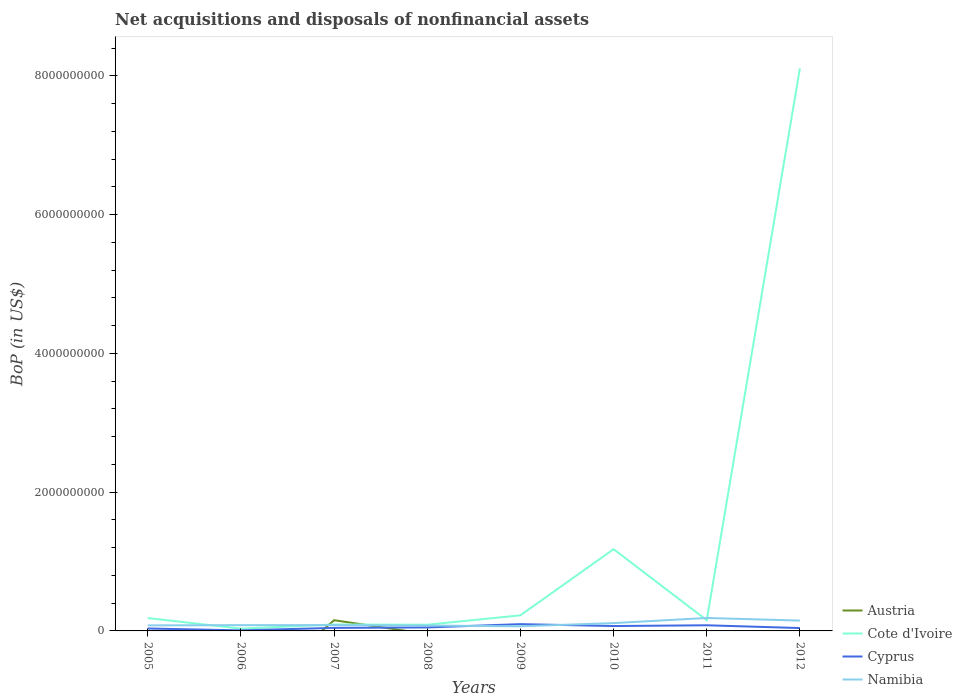How many different coloured lines are there?
Provide a succinct answer. 4. Is the number of lines equal to the number of legend labels?
Your answer should be very brief. No. What is the total Balance of Payments in Cyprus in the graph?
Your answer should be very brief. -3.55e+07. What is the difference between the highest and the second highest Balance of Payments in Namibia?
Give a very brief answer. 1.20e+08. How many lines are there?
Ensure brevity in your answer.  4. How many years are there in the graph?
Offer a very short reply. 8. Are the values on the major ticks of Y-axis written in scientific E-notation?
Offer a very short reply. No. Does the graph contain grids?
Your response must be concise. No. How many legend labels are there?
Provide a succinct answer. 4. How are the legend labels stacked?
Your answer should be compact. Vertical. What is the title of the graph?
Keep it short and to the point. Net acquisitions and disposals of nonfinancial assets. Does "Andorra" appear as one of the legend labels in the graph?
Make the answer very short. No. What is the label or title of the X-axis?
Provide a short and direct response. Years. What is the label or title of the Y-axis?
Provide a short and direct response. BoP (in US$). What is the BoP (in US$) of Cote d'Ivoire in 2005?
Provide a short and direct response. 1.85e+08. What is the BoP (in US$) in Cyprus in 2005?
Provide a short and direct response. 3.49e+07. What is the BoP (in US$) of Namibia in 2005?
Offer a terse response. 7.97e+07. What is the BoP (in US$) of Cote d'Ivoire in 2006?
Your response must be concise. 3.30e+07. What is the BoP (in US$) in Cyprus in 2006?
Give a very brief answer. 7.90e+06. What is the BoP (in US$) of Namibia in 2006?
Offer a terse response. 8.34e+07. What is the BoP (in US$) of Austria in 2007?
Give a very brief answer. 1.54e+08. What is the BoP (in US$) of Cote d'Ivoire in 2007?
Ensure brevity in your answer.  9.29e+07. What is the BoP (in US$) in Cyprus in 2007?
Your answer should be very brief. 4.38e+07. What is the BoP (in US$) in Namibia in 2007?
Your answer should be compact. 8.34e+07. What is the BoP (in US$) in Austria in 2008?
Offer a very short reply. 0. What is the BoP (in US$) in Cote d'Ivoire in 2008?
Offer a very short reply. 8.93e+07. What is the BoP (in US$) in Cyprus in 2008?
Give a very brief answer. 5.03e+07. What is the BoP (in US$) of Namibia in 2008?
Offer a very short reply. 7.72e+07. What is the BoP (in US$) in Cote d'Ivoire in 2009?
Your response must be concise. 2.25e+08. What is the BoP (in US$) of Cyprus in 2009?
Your response must be concise. 9.77e+07. What is the BoP (in US$) in Namibia in 2009?
Your answer should be very brief. 6.68e+07. What is the BoP (in US$) of Austria in 2010?
Keep it short and to the point. 0. What is the BoP (in US$) of Cote d'Ivoire in 2010?
Provide a succinct answer. 1.18e+09. What is the BoP (in US$) of Cyprus in 2010?
Your answer should be very brief. 7.04e+07. What is the BoP (in US$) of Namibia in 2010?
Your response must be concise. 1.13e+08. What is the BoP (in US$) in Cote d'Ivoire in 2011?
Keep it short and to the point. 1.55e+08. What is the BoP (in US$) of Cyprus in 2011?
Offer a terse response. 8.13e+07. What is the BoP (in US$) of Namibia in 2011?
Your response must be concise. 1.87e+08. What is the BoP (in US$) of Cote d'Ivoire in 2012?
Provide a succinct answer. 8.11e+09. What is the BoP (in US$) in Cyprus in 2012?
Give a very brief answer. 4.13e+07. What is the BoP (in US$) of Namibia in 2012?
Make the answer very short. 1.49e+08. Across all years, what is the maximum BoP (in US$) in Austria?
Give a very brief answer. 1.54e+08. Across all years, what is the maximum BoP (in US$) in Cote d'Ivoire?
Your answer should be compact. 8.11e+09. Across all years, what is the maximum BoP (in US$) in Cyprus?
Your answer should be very brief. 9.77e+07. Across all years, what is the maximum BoP (in US$) of Namibia?
Provide a short and direct response. 1.87e+08. Across all years, what is the minimum BoP (in US$) of Austria?
Your answer should be compact. 0. Across all years, what is the minimum BoP (in US$) in Cote d'Ivoire?
Give a very brief answer. 3.30e+07. Across all years, what is the minimum BoP (in US$) of Cyprus?
Your answer should be compact. 7.90e+06. Across all years, what is the minimum BoP (in US$) in Namibia?
Provide a succinct answer. 6.68e+07. What is the total BoP (in US$) of Austria in the graph?
Provide a succinct answer. 1.54e+08. What is the total BoP (in US$) of Cote d'Ivoire in the graph?
Make the answer very short. 1.01e+1. What is the total BoP (in US$) in Cyprus in the graph?
Your answer should be very brief. 4.28e+08. What is the total BoP (in US$) of Namibia in the graph?
Provide a short and direct response. 8.39e+08. What is the difference between the BoP (in US$) in Cote d'Ivoire in 2005 and that in 2006?
Offer a very short reply. 1.52e+08. What is the difference between the BoP (in US$) of Cyprus in 2005 and that in 2006?
Offer a very short reply. 2.70e+07. What is the difference between the BoP (in US$) in Namibia in 2005 and that in 2006?
Provide a short and direct response. -3.73e+06. What is the difference between the BoP (in US$) in Cote d'Ivoire in 2005 and that in 2007?
Your answer should be very brief. 9.24e+07. What is the difference between the BoP (in US$) in Cyprus in 2005 and that in 2007?
Ensure brevity in your answer.  -8.91e+06. What is the difference between the BoP (in US$) of Namibia in 2005 and that in 2007?
Offer a terse response. -3.75e+06. What is the difference between the BoP (in US$) of Cote d'Ivoire in 2005 and that in 2008?
Offer a terse response. 9.59e+07. What is the difference between the BoP (in US$) in Cyprus in 2005 and that in 2008?
Offer a terse response. -1.54e+07. What is the difference between the BoP (in US$) in Namibia in 2005 and that in 2008?
Provide a succinct answer. 2.45e+06. What is the difference between the BoP (in US$) in Cote d'Ivoire in 2005 and that in 2009?
Give a very brief answer. -3.97e+07. What is the difference between the BoP (in US$) in Cyprus in 2005 and that in 2009?
Provide a short and direct response. -6.28e+07. What is the difference between the BoP (in US$) in Namibia in 2005 and that in 2009?
Make the answer very short. 1.29e+07. What is the difference between the BoP (in US$) of Cote d'Ivoire in 2005 and that in 2010?
Ensure brevity in your answer.  -9.93e+08. What is the difference between the BoP (in US$) of Cyprus in 2005 and that in 2010?
Your answer should be compact. -3.55e+07. What is the difference between the BoP (in US$) in Namibia in 2005 and that in 2010?
Your answer should be compact. -3.29e+07. What is the difference between the BoP (in US$) of Cote d'Ivoire in 2005 and that in 2011?
Your response must be concise. 3.06e+07. What is the difference between the BoP (in US$) of Cyprus in 2005 and that in 2011?
Your response must be concise. -4.64e+07. What is the difference between the BoP (in US$) of Namibia in 2005 and that in 2011?
Your answer should be very brief. -1.07e+08. What is the difference between the BoP (in US$) in Cote d'Ivoire in 2005 and that in 2012?
Provide a succinct answer. -7.93e+09. What is the difference between the BoP (in US$) of Cyprus in 2005 and that in 2012?
Your answer should be very brief. -6.39e+06. What is the difference between the BoP (in US$) of Namibia in 2005 and that in 2012?
Your response must be concise. -6.92e+07. What is the difference between the BoP (in US$) of Cote d'Ivoire in 2006 and that in 2007?
Provide a short and direct response. -5.99e+07. What is the difference between the BoP (in US$) in Cyprus in 2006 and that in 2007?
Give a very brief answer. -3.59e+07. What is the difference between the BoP (in US$) in Namibia in 2006 and that in 2007?
Your answer should be compact. -2.69e+04. What is the difference between the BoP (in US$) in Cote d'Ivoire in 2006 and that in 2008?
Offer a very short reply. -5.63e+07. What is the difference between the BoP (in US$) in Cyprus in 2006 and that in 2008?
Provide a succinct answer. -4.24e+07. What is the difference between the BoP (in US$) in Namibia in 2006 and that in 2008?
Offer a terse response. 6.18e+06. What is the difference between the BoP (in US$) of Cote d'Ivoire in 2006 and that in 2009?
Ensure brevity in your answer.  -1.92e+08. What is the difference between the BoP (in US$) in Cyprus in 2006 and that in 2009?
Provide a short and direct response. -8.98e+07. What is the difference between the BoP (in US$) in Namibia in 2006 and that in 2009?
Provide a short and direct response. 1.66e+07. What is the difference between the BoP (in US$) of Cote d'Ivoire in 2006 and that in 2010?
Make the answer very short. -1.15e+09. What is the difference between the BoP (in US$) of Cyprus in 2006 and that in 2010?
Offer a very short reply. -6.25e+07. What is the difference between the BoP (in US$) in Namibia in 2006 and that in 2010?
Make the answer very short. -2.92e+07. What is the difference between the BoP (in US$) of Cote d'Ivoire in 2006 and that in 2011?
Your answer should be very brief. -1.22e+08. What is the difference between the BoP (in US$) of Cyprus in 2006 and that in 2011?
Your response must be concise. -7.34e+07. What is the difference between the BoP (in US$) of Namibia in 2006 and that in 2011?
Provide a succinct answer. -1.03e+08. What is the difference between the BoP (in US$) of Cote d'Ivoire in 2006 and that in 2012?
Make the answer very short. -8.08e+09. What is the difference between the BoP (in US$) in Cyprus in 2006 and that in 2012?
Provide a short and direct response. -3.34e+07. What is the difference between the BoP (in US$) of Namibia in 2006 and that in 2012?
Provide a short and direct response. -6.54e+07. What is the difference between the BoP (in US$) in Cote d'Ivoire in 2007 and that in 2008?
Provide a short and direct response. 3.56e+06. What is the difference between the BoP (in US$) in Cyprus in 2007 and that in 2008?
Your answer should be compact. -6.48e+06. What is the difference between the BoP (in US$) of Namibia in 2007 and that in 2008?
Your response must be concise. 6.20e+06. What is the difference between the BoP (in US$) of Cote d'Ivoire in 2007 and that in 2009?
Provide a short and direct response. -1.32e+08. What is the difference between the BoP (in US$) of Cyprus in 2007 and that in 2009?
Ensure brevity in your answer.  -5.39e+07. What is the difference between the BoP (in US$) of Namibia in 2007 and that in 2009?
Give a very brief answer. 1.66e+07. What is the difference between the BoP (in US$) of Cote d'Ivoire in 2007 and that in 2010?
Provide a short and direct response. -1.09e+09. What is the difference between the BoP (in US$) in Cyprus in 2007 and that in 2010?
Your response must be concise. -2.66e+07. What is the difference between the BoP (in US$) in Namibia in 2007 and that in 2010?
Your answer should be very brief. -2.92e+07. What is the difference between the BoP (in US$) in Cote d'Ivoire in 2007 and that in 2011?
Your response must be concise. -6.18e+07. What is the difference between the BoP (in US$) in Cyprus in 2007 and that in 2011?
Provide a short and direct response. -3.75e+07. What is the difference between the BoP (in US$) in Namibia in 2007 and that in 2011?
Your answer should be very brief. -1.03e+08. What is the difference between the BoP (in US$) in Cote d'Ivoire in 2007 and that in 2012?
Ensure brevity in your answer.  -8.02e+09. What is the difference between the BoP (in US$) of Cyprus in 2007 and that in 2012?
Provide a short and direct response. 2.52e+06. What is the difference between the BoP (in US$) in Namibia in 2007 and that in 2012?
Give a very brief answer. -6.54e+07. What is the difference between the BoP (in US$) in Cote d'Ivoire in 2008 and that in 2009?
Offer a terse response. -1.36e+08. What is the difference between the BoP (in US$) in Cyprus in 2008 and that in 2009?
Keep it short and to the point. -4.74e+07. What is the difference between the BoP (in US$) in Namibia in 2008 and that in 2009?
Your answer should be compact. 1.04e+07. What is the difference between the BoP (in US$) in Cote d'Ivoire in 2008 and that in 2010?
Your answer should be compact. -1.09e+09. What is the difference between the BoP (in US$) of Cyprus in 2008 and that in 2010?
Give a very brief answer. -2.01e+07. What is the difference between the BoP (in US$) of Namibia in 2008 and that in 2010?
Provide a succinct answer. -3.54e+07. What is the difference between the BoP (in US$) of Cote d'Ivoire in 2008 and that in 2011?
Keep it short and to the point. -6.53e+07. What is the difference between the BoP (in US$) of Cyprus in 2008 and that in 2011?
Your response must be concise. -3.10e+07. What is the difference between the BoP (in US$) in Namibia in 2008 and that in 2011?
Ensure brevity in your answer.  -1.10e+08. What is the difference between the BoP (in US$) in Cote d'Ivoire in 2008 and that in 2012?
Your answer should be compact. -8.02e+09. What is the difference between the BoP (in US$) in Cyprus in 2008 and that in 2012?
Keep it short and to the point. 9.00e+06. What is the difference between the BoP (in US$) in Namibia in 2008 and that in 2012?
Your response must be concise. -7.16e+07. What is the difference between the BoP (in US$) of Cote d'Ivoire in 2009 and that in 2010?
Offer a terse response. -9.53e+08. What is the difference between the BoP (in US$) in Cyprus in 2009 and that in 2010?
Give a very brief answer. 2.73e+07. What is the difference between the BoP (in US$) in Namibia in 2009 and that in 2010?
Provide a succinct answer. -4.58e+07. What is the difference between the BoP (in US$) of Cote d'Ivoire in 2009 and that in 2011?
Your response must be concise. 7.03e+07. What is the difference between the BoP (in US$) of Cyprus in 2009 and that in 2011?
Your answer should be compact. 1.64e+07. What is the difference between the BoP (in US$) in Namibia in 2009 and that in 2011?
Your response must be concise. -1.20e+08. What is the difference between the BoP (in US$) of Cote d'Ivoire in 2009 and that in 2012?
Offer a terse response. -7.89e+09. What is the difference between the BoP (in US$) in Cyprus in 2009 and that in 2012?
Your answer should be very brief. 5.64e+07. What is the difference between the BoP (in US$) in Namibia in 2009 and that in 2012?
Provide a succinct answer. -8.21e+07. What is the difference between the BoP (in US$) of Cote d'Ivoire in 2010 and that in 2011?
Provide a succinct answer. 1.02e+09. What is the difference between the BoP (in US$) of Cyprus in 2010 and that in 2011?
Make the answer very short. -1.09e+07. What is the difference between the BoP (in US$) in Namibia in 2010 and that in 2011?
Make the answer very short. -7.42e+07. What is the difference between the BoP (in US$) of Cote d'Ivoire in 2010 and that in 2012?
Your answer should be compact. -6.93e+09. What is the difference between the BoP (in US$) of Cyprus in 2010 and that in 2012?
Keep it short and to the point. 2.91e+07. What is the difference between the BoP (in US$) in Namibia in 2010 and that in 2012?
Keep it short and to the point. -3.63e+07. What is the difference between the BoP (in US$) of Cote d'Ivoire in 2011 and that in 2012?
Your answer should be compact. -7.96e+09. What is the difference between the BoP (in US$) in Cyprus in 2011 and that in 2012?
Offer a very short reply. 4.01e+07. What is the difference between the BoP (in US$) of Namibia in 2011 and that in 2012?
Provide a succinct answer. 3.79e+07. What is the difference between the BoP (in US$) in Cote d'Ivoire in 2005 and the BoP (in US$) in Cyprus in 2006?
Ensure brevity in your answer.  1.77e+08. What is the difference between the BoP (in US$) of Cote d'Ivoire in 2005 and the BoP (in US$) of Namibia in 2006?
Make the answer very short. 1.02e+08. What is the difference between the BoP (in US$) of Cyprus in 2005 and the BoP (in US$) of Namibia in 2006?
Offer a terse response. -4.85e+07. What is the difference between the BoP (in US$) in Cote d'Ivoire in 2005 and the BoP (in US$) in Cyprus in 2007?
Give a very brief answer. 1.41e+08. What is the difference between the BoP (in US$) in Cote d'Ivoire in 2005 and the BoP (in US$) in Namibia in 2007?
Make the answer very short. 1.02e+08. What is the difference between the BoP (in US$) of Cyprus in 2005 and the BoP (in US$) of Namibia in 2007?
Offer a terse response. -4.85e+07. What is the difference between the BoP (in US$) of Cote d'Ivoire in 2005 and the BoP (in US$) of Cyprus in 2008?
Keep it short and to the point. 1.35e+08. What is the difference between the BoP (in US$) in Cote d'Ivoire in 2005 and the BoP (in US$) in Namibia in 2008?
Offer a very short reply. 1.08e+08. What is the difference between the BoP (in US$) of Cyprus in 2005 and the BoP (in US$) of Namibia in 2008?
Offer a very short reply. -4.23e+07. What is the difference between the BoP (in US$) of Cote d'Ivoire in 2005 and the BoP (in US$) of Cyprus in 2009?
Offer a terse response. 8.75e+07. What is the difference between the BoP (in US$) in Cote d'Ivoire in 2005 and the BoP (in US$) in Namibia in 2009?
Give a very brief answer. 1.18e+08. What is the difference between the BoP (in US$) of Cyprus in 2005 and the BoP (in US$) of Namibia in 2009?
Provide a succinct answer. -3.19e+07. What is the difference between the BoP (in US$) of Cote d'Ivoire in 2005 and the BoP (in US$) of Cyprus in 2010?
Keep it short and to the point. 1.15e+08. What is the difference between the BoP (in US$) in Cote d'Ivoire in 2005 and the BoP (in US$) in Namibia in 2010?
Make the answer very short. 7.27e+07. What is the difference between the BoP (in US$) in Cyprus in 2005 and the BoP (in US$) in Namibia in 2010?
Keep it short and to the point. -7.77e+07. What is the difference between the BoP (in US$) of Cote d'Ivoire in 2005 and the BoP (in US$) of Cyprus in 2011?
Make the answer very short. 1.04e+08. What is the difference between the BoP (in US$) in Cote d'Ivoire in 2005 and the BoP (in US$) in Namibia in 2011?
Your response must be concise. -1.54e+06. What is the difference between the BoP (in US$) in Cyprus in 2005 and the BoP (in US$) in Namibia in 2011?
Your answer should be very brief. -1.52e+08. What is the difference between the BoP (in US$) of Cote d'Ivoire in 2005 and the BoP (in US$) of Cyprus in 2012?
Provide a succinct answer. 1.44e+08. What is the difference between the BoP (in US$) in Cote d'Ivoire in 2005 and the BoP (in US$) in Namibia in 2012?
Your response must be concise. 3.64e+07. What is the difference between the BoP (in US$) in Cyprus in 2005 and the BoP (in US$) in Namibia in 2012?
Provide a short and direct response. -1.14e+08. What is the difference between the BoP (in US$) of Cote d'Ivoire in 2006 and the BoP (in US$) of Cyprus in 2007?
Provide a succinct answer. -1.08e+07. What is the difference between the BoP (in US$) of Cote d'Ivoire in 2006 and the BoP (in US$) of Namibia in 2007?
Provide a succinct answer. -5.04e+07. What is the difference between the BoP (in US$) in Cyprus in 2006 and the BoP (in US$) in Namibia in 2007?
Your answer should be compact. -7.55e+07. What is the difference between the BoP (in US$) in Cote d'Ivoire in 2006 and the BoP (in US$) in Cyprus in 2008?
Your response must be concise. -1.73e+07. What is the difference between the BoP (in US$) of Cote d'Ivoire in 2006 and the BoP (in US$) of Namibia in 2008?
Your answer should be compact. -4.42e+07. What is the difference between the BoP (in US$) of Cyprus in 2006 and the BoP (in US$) of Namibia in 2008?
Make the answer very short. -6.93e+07. What is the difference between the BoP (in US$) in Cote d'Ivoire in 2006 and the BoP (in US$) in Cyprus in 2009?
Your response must be concise. -6.47e+07. What is the difference between the BoP (in US$) of Cote d'Ivoire in 2006 and the BoP (in US$) of Namibia in 2009?
Provide a short and direct response. -3.38e+07. What is the difference between the BoP (in US$) of Cyprus in 2006 and the BoP (in US$) of Namibia in 2009?
Give a very brief answer. -5.89e+07. What is the difference between the BoP (in US$) of Cote d'Ivoire in 2006 and the BoP (in US$) of Cyprus in 2010?
Provide a succinct answer. -3.74e+07. What is the difference between the BoP (in US$) in Cote d'Ivoire in 2006 and the BoP (in US$) in Namibia in 2010?
Ensure brevity in your answer.  -7.96e+07. What is the difference between the BoP (in US$) in Cyprus in 2006 and the BoP (in US$) in Namibia in 2010?
Offer a very short reply. -1.05e+08. What is the difference between the BoP (in US$) in Cote d'Ivoire in 2006 and the BoP (in US$) in Cyprus in 2011?
Keep it short and to the point. -4.83e+07. What is the difference between the BoP (in US$) in Cote d'Ivoire in 2006 and the BoP (in US$) in Namibia in 2011?
Provide a succinct answer. -1.54e+08. What is the difference between the BoP (in US$) in Cyprus in 2006 and the BoP (in US$) in Namibia in 2011?
Give a very brief answer. -1.79e+08. What is the difference between the BoP (in US$) of Cote d'Ivoire in 2006 and the BoP (in US$) of Cyprus in 2012?
Your response must be concise. -8.29e+06. What is the difference between the BoP (in US$) of Cote d'Ivoire in 2006 and the BoP (in US$) of Namibia in 2012?
Offer a terse response. -1.16e+08. What is the difference between the BoP (in US$) of Cyprus in 2006 and the BoP (in US$) of Namibia in 2012?
Offer a very short reply. -1.41e+08. What is the difference between the BoP (in US$) of Austria in 2007 and the BoP (in US$) of Cote d'Ivoire in 2008?
Your response must be concise. 6.51e+07. What is the difference between the BoP (in US$) of Austria in 2007 and the BoP (in US$) of Cyprus in 2008?
Offer a terse response. 1.04e+08. What is the difference between the BoP (in US$) in Austria in 2007 and the BoP (in US$) in Namibia in 2008?
Provide a succinct answer. 7.72e+07. What is the difference between the BoP (in US$) in Cote d'Ivoire in 2007 and the BoP (in US$) in Cyprus in 2008?
Provide a succinct answer. 4.26e+07. What is the difference between the BoP (in US$) in Cote d'Ivoire in 2007 and the BoP (in US$) in Namibia in 2008?
Provide a succinct answer. 1.57e+07. What is the difference between the BoP (in US$) of Cyprus in 2007 and the BoP (in US$) of Namibia in 2008?
Offer a very short reply. -3.34e+07. What is the difference between the BoP (in US$) of Austria in 2007 and the BoP (in US$) of Cote d'Ivoire in 2009?
Your answer should be compact. -7.05e+07. What is the difference between the BoP (in US$) in Austria in 2007 and the BoP (in US$) in Cyprus in 2009?
Make the answer very short. 5.67e+07. What is the difference between the BoP (in US$) of Austria in 2007 and the BoP (in US$) of Namibia in 2009?
Ensure brevity in your answer.  8.76e+07. What is the difference between the BoP (in US$) in Cote d'Ivoire in 2007 and the BoP (in US$) in Cyprus in 2009?
Give a very brief answer. -4.82e+06. What is the difference between the BoP (in US$) of Cote d'Ivoire in 2007 and the BoP (in US$) of Namibia in 2009?
Give a very brief answer. 2.61e+07. What is the difference between the BoP (in US$) of Cyprus in 2007 and the BoP (in US$) of Namibia in 2009?
Keep it short and to the point. -2.30e+07. What is the difference between the BoP (in US$) of Austria in 2007 and the BoP (in US$) of Cote d'Ivoire in 2010?
Give a very brief answer. -1.02e+09. What is the difference between the BoP (in US$) in Austria in 2007 and the BoP (in US$) in Cyprus in 2010?
Keep it short and to the point. 8.40e+07. What is the difference between the BoP (in US$) of Austria in 2007 and the BoP (in US$) of Namibia in 2010?
Ensure brevity in your answer.  4.18e+07. What is the difference between the BoP (in US$) in Cote d'Ivoire in 2007 and the BoP (in US$) in Cyprus in 2010?
Make the answer very short. 2.25e+07. What is the difference between the BoP (in US$) in Cote d'Ivoire in 2007 and the BoP (in US$) in Namibia in 2010?
Offer a terse response. -1.97e+07. What is the difference between the BoP (in US$) of Cyprus in 2007 and the BoP (in US$) of Namibia in 2010?
Provide a short and direct response. -6.88e+07. What is the difference between the BoP (in US$) of Austria in 2007 and the BoP (in US$) of Cote d'Ivoire in 2011?
Provide a succinct answer. -2.55e+05. What is the difference between the BoP (in US$) of Austria in 2007 and the BoP (in US$) of Cyprus in 2011?
Offer a terse response. 7.31e+07. What is the difference between the BoP (in US$) in Austria in 2007 and the BoP (in US$) in Namibia in 2011?
Your response must be concise. -3.24e+07. What is the difference between the BoP (in US$) in Cote d'Ivoire in 2007 and the BoP (in US$) in Cyprus in 2011?
Your answer should be very brief. 1.16e+07. What is the difference between the BoP (in US$) in Cote d'Ivoire in 2007 and the BoP (in US$) in Namibia in 2011?
Provide a succinct answer. -9.39e+07. What is the difference between the BoP (in US$) of Cyprus in 2007 and the BoP (in US$) of Namibia in 2011?
Your answer should be very brief. -1.43e+08. What is the difference between the BoP (in US$) of Austria in 2007 and the BoP (in US$) of Cote d'Ivoire in 2012?
Give a very brief answer. -7.96e+09. What is the difference between the BoP (in US$) in Austria in 2007 and the BoP (in US$) in Cyprus in 2012?
Offer a terse response. 1.13e+08. What is the difference between the BoP (in US$) in Austria in 2007 and the BoP (in US$) in Namibia in 2012?
Offer a terse response. 5.57e+06. What is the difference between the BoP (in US$) in Cote d'Ivoire in 2007 and the BoP (in US$) in Cyprus in 2012?
Give a very brief answer. 5.16e+07. What is the difference between the BoP (in US$) of Cote d'Ivoire in 2007 and the BoP (in US$) of Namibia in 2012?
Your answer should be very brief. -5.59e+07. What is the difference between the BoP (in US$) of Cyprus in 2007 and the BoP (in US$) of Namibia in 2012?
Ensure brevity in your answer.  -1.05e+08. What is the difference between the BoP (in US$) in Cote d'Ivoire in 2008 and the BoP (in US$) in Cyprus in 2009?
Keep it short and to the point. -8.38e+06. What is the difference between the BoP (in US$) of Cote d'Ivoire in 2008 and the BoP (in US$) of Namibia in 2009?
Offer a terse response. 2.25e+07. What is the difference between the BoP (in US$) in Cyprus in 2008 and the BoP (in US$) in Namibia in 2009?
Provide a short and direct response. -1.65e+07. What is the difference between the BoP (in US$) in Cote d'Ivoire in 2008 and the BoP (in US$) in Cyprus in 2010?
Make the answer very short. 1.89e+07. What is the difference between the BoP (in US$) in Cote d'Ivoire in 2008 and the BoP (in US$) in Namibia in 2010?
Keep it short and to the point. -2.32e+07. What is the difference between the BoP (in US$) of Cyprus in 2008 and the BoP (in US$) of Namibia in 2010?
Provide a short and direct response. -6.23e+07. What is the difference between the BoP (in US$) of Cote d'Ivoire in 2008 and the BoP (in US$) of Cyprus in 2011?
Your response must be concise. 7.99e+06. What is the difference between the BoP (in US$) in Cote d'Ivoire in 2008 and the BoP (in US$) in Namibia in 2011?
Keep it short and to the point. -9.75e+07. What is the difference between the BoP (in US$) of Cyprus in 2008 and the BoP (in US$) of Namibia in 2011?
Provide a succinct answer. -1.36e+08. What is the difference between the BoP (in US$) in Cote d'Ivoire in 2008 and the BoP (in US$) in Cyprus in 2012?
Provide a short and direct response. 4.80e+07. What is the difference between the BoP (in US$) of Cote d'Ivoire in 2008 and the BoP (in US$) of Namibia in 2012?
Give a very brief answer. -5.95e+07. What is the difference between the BoP (in US$) in Cyprus in 2008 and the BoP (in US$) in Namibia in 2012?
Ensure brevity in your answer.  -9.86e+07. What is the difference between the BoP (in US$) of Cote d'Ivoire in 2009 and the BoP (in US$) of Cyprus in 2010?
Offer a terse response. 1.55e+08. What is the difference between the BoP (in US$) of Cote d'Ivoire in 2009 and the BoP (in US$) of Namibia in 2010?
Keep it short and to the point. 1.12e+08. What is the difference between the BoP (in US$) in Cyprus in 2009 and the BoP (in US$) in Namibia in 2010?
Provide a succinct answer. -1.49e+07. What is the difference between the BoP (in US$) in Cote d'Ivoire in 2009 and the BoP (in US$) in Cyprus in 2011?
Ensure brevity in your answer.  1.44e+08. What is the difference between the BoP (in US$) in Cote d'Ivoire in 2009 and the BoP (in US$) in Namibia in 2011?
Provide a short and direct response. 3.82e+07. What is the difference between the BoP (in US$) of Cyprus in 2009 and the BoP (in US$) of Namibia in 2011?
Offer a terse response. -8.91e+07. What is the difference between the BoP (in US$) in Cote d'Ivoire in 2009 and the BoP (in US$) in Cyprus in 2012?
Ensure brevity in your answer.  1.84e+08. What is the difference between the BoP (in US$) of Cote d'Ivoire in 2009 and the BoP (in US$) of Namibia in 2012?
Make the answer very short. 7.61e+07. What is the difference between the BoP (in US$) of Cyprus in 2009 and the BoP (in US$) of Namibia in 2012?
Your response must be concise. -5.11e+07. What is the difference between the BoP (in US$) of Cote d'Ivoire in 2010 and the BoP (in US$) of Cyprus in 2011?
Provide a short and direct response. 1.10e+09. What is the difference between the BoP (in US$) in Cote d'Ivoire in 2010 and the BoP (in US$) in Namibia in 2011?
Provide a succinct answer. 9.92e+08. What is the difference between the BoP (in US$) in Cyprus in 2010 and the BoP (in US$) in Namibia in 2011?
Offer a very short reply. -1.16e+08. What is the difference between the BoP (in US$) of Cote d'Ivoire in 2010 and the BoP (in US$) of Cyprus in 2012?
Keep it short and to the point. 1.14e+09. What is the difference between the BoP (in US$) of Cote d'Ivoire in 2010 and the BoP (in US$) of Namibia in 2012?
Offer a very short reply. 1.03e+09. What is the difference between the BoP (in US$) of Cyprus in 2010 and the BoP (in US$) of Namibia in 2012?
Make the answer very short. -7.84e+07. What is the difference between the BoP (in US$) of Cote d'Ivoire in 2011 and the BoP (in US$) of Cyprus in 2012?
Your answer should be compact. 1.13e+08. What is the difference between the BoP (in US$) in Cote d'Ivoire in 2011 and the BoP (in US$) in Namibia in 2012?
Your answer should be compact. 5.82e+06. What is the difference between the BoP (in US$) in Cyprus in 2011 and the BoP (in US$) in Namibia in 2012?
Make the answer very short. -6.75e+07. What is the average BoP (in US$) of Austria per year?
Provide a short and direct response. 1.93e+07. What is the average BoP (in US$) in Cote d'Ivoire per year?
Your response must be concise. 1.26e+09. What is the average BoP (in US$) in Cyprus per year?
Keep it short and to the point. 5.34e+07. What is the average BoP (in US$) in Namibia per year?
Offer a terse response. 1.05e+08. In the year 2005, what is the difference between the BoP (in US$) of Cote d'Ivoire and BoP (in US$) of Cyprus?
Provide a short and direct response. 1.50e+08. In the year 2005, what is the difference between the BoP (in US$) of Cote d'Ivoire and BoP (in US$) of Namibia?
Keep it short and to the point. 1.06e+08. In the year 2005, what is the difference between the BoP (in US$) in Cyprus and BoP (in US$) in Namibia?
Offer a very short reply. -4.48e+07. In the year 2006, what is the difference between the BoP (in US$) in Cote d'Ivoire and BoP (in US$) in Cyprus?
Your answer should be compact. 2.51e+07. In the year 2006, what is the difference between the BoP (in US$) in Cote d'Ivoire and BoP (in US$) in Namibia?
Ensure brevity in your answer.  -5.04e+07. In the year 2006, what is the difference between the BoP (in US$) in Cyprus and BoP (in US$) in Namibia?
Provide a short and direct response. -7.55e+07. In the year 2007, what is the difference between the BoP (in US$) of Austria and BoP (in US$) of Cote d'Ivoire?
Your answer should be compact. 6.15e+07. In the year 2007, what is the difference between the BoP (in US$) in Austria and BoP (in US$) in Cyprus?
Make the answer very short. 1.11e+08. In the year 2007, what is the difference between the BoP (in US$) of Austria and BoP (in US$) of Namibia?
Offer a terse response. 7.10e+07. In the year 2007, what is the difference between the BoP (in US$) of Cote d'Ivoire and BoP (in US$) of Cyprus?
Provide a succinct answer. 4.91e+07. In the year 2007, what is the difference between the BoP (in US$) of Cote d'Ivoire and BoP (in US$) of Namibia?
Your response must be concise. 9.47e+06. In the year 2007, what is the difference between the BoP (in US$) of Cyprus and BoP (in US$) of Namibia?
Make the answer very short. -3.96e+07. In the year 2008, what is the difference between the BoP (in US$) in Cote d'Ivoire and BoP (in US$) in Cyprus?
Give a very brief answer. 3.90e+07. In the year 2008, what is the difference between the BoP (in US$) of Cote d'Ivoire and BoP (in US$) of Namibia?
Make the answer very short. 1.21e+07. In the year 2008, what is the difference between the BoP (in US$) of Cyprus and BoP (in US$) of Namibia?
Make the answer very short. -2.69e+07. In the year 2009, what is the difference between the BoP (in US$) of Cote d'Ivoire and BoP (in US$) of Cyprus?
Ensure brevity in your answer.  1.27e+08. In the year 2009, what is the difference between the BoP (in US$) of Cote d'Ivoire and BoP (in US$) of Namibia?
Your answer should be very brief. 1.58e+08. In the year 2009, what is the difference between the BoP (in US$) in Cyprus and BoP (in US$) in Namibia?
Offer a very short reply. 3.09e+07. In the year 2010, what is the difference between the BoP (in US$) of Cote d'Ivoire and BoP (in US$) of Cyprus?
Your answer should be compact. 1.11e+09. In the year 2010, what is the difference between the BoP (in US$) of Cote d'Ivoire and BoP (in US$) of Namibia?
Offer a terse response. 1.07e+09. In the year 2010, what is the difference between the BoP (in US$) of Cyprus and BoP (in US$) of Namibia?
Offer a terse response. -4.22e+07. In the year 2011, what is the difference between the BoP (in US$) in Cote d'Ivoire and BoP (in US$) in Cyprus?
Make the answer very short. 7.33e+07. In the year 2011, what is the difference between the BoP (in US$) in Cote d'Ivoire and BoP (in US$) in Namibia?
Provide a succinct answer. -3.21e+07. In the year 2011, what is the difference between the BoP (in US$) of Cyprus and BoP (in US$) of Namibia?
Provide a succinct answer. -1.05e+08. In the year 2012, what is the difference between the BoP (in US$) in Cote d'Ivoire and BoP (in US$) in Cyprus?
Ensure brevity in your answer.  8.07e+09. In the year 2012, what is the difference between the BoP (in US$) of Cote d'Ivoire and BoP (in US$) of Namibia?
Your answer should be very brief. 7.96e+09. In the year 2012, what is the difference between the BoP (in US$) of Cyprus and BoP (in US$) of Namibia?
Give a very brief answer. -1.08e+08. What is the ratio of the BoP (in US$) of Cote d'Ivoire in 2005 to that in 2006?
Provide a short and direct response. 5.62. What is the ratio of the BoP (in US$) in Cyprus in 2005 to that in 2006?
Ensure brevity in your answer.  4.42. What is the ratio of the BoP (in US$) of Namibia in 2005 to that in 2006?
Your answer should be very brief. 0.96. What is the ratio of the BoP (in US$) in Cote d'Ivoire in 2005 to that in 2007?
Offer a very short reply. 1.99. What is the ratio of the BoP (in US$) of Cyprus in 2005 to that in 2007?
Give a very brief answer. 0.8. What is the ratio of the BoP (in US$) of Namibia in 2005 to that in 2007?
Your answer should be very brief. 0.95. What is the ratio of the BoP (in US$) in Cote d'Ivoire in 2005 to that in 2008?
Offer a terse response. 2.07. What is the ratio of the BoP (in US$) in Cyprus in 2005 to that in 2008?
Offer a very short reply. 0.69. What is the ratio of the BoP (in US$) of Namibia in 2005 to that in 2008?
Give a very brief answer. 1.03. What is the ratio of the BoP (in US$) of Cote d'Ivoire in 2005 to that in 2009?
Provide a succinct answer. 0.82. What is the ratio of the BoP (in US$) in Cyprus in 2005 to that in 2009?
Give a very brief answer. 0.36. What is the ratio of the BoP (in US$) in Namibia in 2005 to that in 2009?
Offer a terse response. 1.19. What is the ratio of the BoP (in US$) of Cote d'Ivoire in 2005 to that in 2010?
Your answer should be compact. 0.16. What is the ratio of the BoP (in US$) in Cyprus in 2005 to that in 2010?
Ensure brevity in your answer.  0.5. What is the ratio of the BoP (in US$) of Namibia in 2005 to that in 2010?
Your answer should be compact. 0.71. What is the ratio of the BoP (in US$) in Cote d'Ivoire in 2005 to that in 2011?
Provide a short and direct response. 1.2. What is the ratio of the BoP (in US$) in Cyprus in 2005 to that in 2011?
Provide a succinct answer. 0.43. What is the ratio of the BoP (in US$) of Namibia in 2005 to that in 2011?
Provide a succinct answer. 0.43. What is the ratio of the BoP (in US$) of Cote d'Ivoire in 2005 to that in 2012?
Offer a terse response. 0.02. What is the ratio of the BoP (in US$) in Cyprus in 2005 to that in 2012?
Provide a succinct answer. 0.85. What is the ratio of the BoP (in US$) in Namibia in 2005 to that in 2012?
Offer a very short reply. 0.54. What is the ratio of the BoP (in US$) in Cote d'Ivoire in 2006 to that in 2007?
Offer a very short reply. 0.36. What is the ratio of the BoP (in US$) of Cyprus in 2006 to that in 2007?
Your response must be concise. 0.18. What is the ratio of the BoP (in US$) in Cote d'Ivoire in 2006 to that in 2008?
Give a very brief answer. 0.37. What is the ratio of the BoP (in US$) in Cyprus in 2006 to that in 2008?
Your response must be concise. 0.16. What is the ratio of the BoP (in US$) in Cote d'Ivoire in 2006 to that in 2009?
Offer a terse response. 0.15. What is the ratio of the BoP (in US$) in Cyprus in 2006 to that in 2009?
Give a very brief answer. 0.08. What is the ratio of the BoP (in US$) of Namibia in 2006 to that in 2009?
Your answer should be very brief. 1.25. What is the ratio of the BoP (in US$) of Cote d'Ivoire in 2006 to that in 2010?
Your response must be concise. 0.03. What is the ratio of the BoP (in US$) of Cyprus in 2006 to that in 2010?
Provide a short and direct response. 0.11. What is the ratio of the BoP (in US$) of Namibia in 2006 to that in 2010?
Provide a short and direct response. 0.74. What is the ratio of the BoP (in US$) in Cote d'Ivoire in 2006 to that in 2011?
Your response must be concise. 0.21. What is the ratio of the BoP (in US$) in Cyprus in 2006 to that in 2011?
Your answer should be very brief. 0.1. What is the ratio of the BoP (in US$) in Namibia in 2006 to that in 2011?
Your answer should be very brief. 0.45. What is the ratio of the BoP (in US$) of Cote d'Ivoire in 2006 to that in 2012?
Give a very brief answer. 0. What is the ratio of the BoP (in US$) in Cyprus in 2006 to that in 2012?
Offer a terse response. 0.19. What is the ratio of the BoP (in US$) in Namibia in 2006 to that in 2012?
Your response must be concise. 0.56. What is the ratio of the BoP (in US$) in Cote d'Ivoire in 2007 to that in 2008?
Your response must be concise. 1.04. What is the ratio of the BoP (in US$) in Cyprus in 2007 to that in 2008?
Offer a terse response. 0.87. What is the ratio of the BoP (in US$) of Namibia in 2007 to that in 2008?
Give a very brief answer. 1.08. What is the ratio of the BoP (in US$) in Cote d'Ivoire in 2007 to that in 2009?
Keep it short and to the point. 0.41. What is the ratio of the BoP (in US$) in Cyprus in 2007 to that in 2009?
Your answer should be very brief. 0.45. What is the ratio of the BoP (in US$) of Namibia in 2007 to that in 2009?
Offer a terse response. 1.25. What is the ratio of the BoP (in US$) in Cote d'Ivoire in 2007 to that in 2010?
Offer a terse response. 0.08. What is the ratio of the BoP (in US$) of Cyprus in 2007 to that in 2010?
Your answer should be compact. 0.62. What is the ratio of the BoP (in US$) in Namibia in 2007 to that in 2010?
Ensure brevity in your answer.  0.74. What is the ratio of the BoP (in US$) in Cote d'Ivoire in 2007 to that in 2011?
Offer a terse response. 0.6. What is the ratio of the BoP (in US$) in Cyprus in 2007 to that in 2011?
Make the answer very short. 0.54. What is the ratio of the BoP (in US$) of Namibia in 2007 to that in 2011?
Ensure brevity in your answer.  0.45. What is the ratio of the BoP (in US$) of Cote d'Ivoire in 2007 to that in 2012?
Provide a succinct answer. 0.01. What is the ratio of the BoP (in US$) of Cyprus in 2007 to that in 2012?
Give a very brief answer. 1.06. What is the ratio of the BoP (in US$) in Namibia in 2007 to that in 2012?
Keep it short and to the point. 0.56. What is the ratio of the BoP (in US$) in Cote d'Ivoire in 2008 to that in 2009?
Offer a very short reply. 0.4. What is the ratio of the BoP (in US$) of Cyprus in 2008 to that in 2009?
Give a very brief answer. 0.51. What is the ratio of the BoP (in US$) in Namibia in 2008 to that in 2009?
Your answer should be very brief. 1.16. What is the ratio of the BoP (in US$) of Cote d'Ivoire in 2008 to that in 2010?
Provide a succinct answer. 0.08. What is the ratio of the BoP (in US$) of Cyprus in 2008 to that in 2010?
Your answer should be compact. 0.71. What is the ratio of the BoP (in US$) of Namibia in 2008 to that in 2010?
Provide a succinct answer. 0.69. What is the ratio of the BoP (in US$) in Cote d'Ivoire in 2008 to that in 2011?
Make the answer very short. 0.58. What is the ratio of the BoP (in US$) in Cyprus in 2008 to that in 2011?
Give a very brief answer. 0.62. What is the ratio of the BoP (in US$) in Namibia in 2008 to that in 2011?
Offer a terse response. 0.41. What is the ratio of the BoP (in US$) in Cote d'Ivoire in 2008 to that in 2012?
Provide a short and direct response. 0.01. What is the ratio of the BoP (in US$) of Cyprus in 2008 to that in 2012?
Your response must be concise. 1.22. What is the ratio of the BoP (in US$) in Namibia in 2008 to that in 2012?
Your answer should be compact. 0.52. What is the ratio of the BoP (in US$) in Cote d'Ivoire in 2009 to that in 2010?
Provide a succinct answer. 0.19. What is the ratio of the BoP (in US$) in Cyprus in 2009 to that in 2010?
Offer a terse response. 1.39. What is the ratio of the BoP (in US$) of Namibia in 2009 to that in 2010?
Make the answer very short. 0.59. What is the ratio of the BoP (in US$) of Cote d'Ivoire in 2009 to that in 2011?
Offer a terse response. 1.45. What is the ratio of the BoP (in US$) in Cyprus in 2009 to that in 2011?
Your answer should be very brief. 1.2. What is the ratio of the BoP (in US$) of Namibia in 2009 to that in 2011?
Give a very brief answer. 0.36. What is the ratio of the BoP (in US$) in Cote d'Ivoire in 2009 to that in 2012?
Your answer should be compact. 0.03. What is the ratio of the BoP (in US$) in Cyprus in 2009 to that in 2012?
Ensure brevity in your answer.  2.37. What is the ratio of the BoP (in US$) of Namibia in 2009 to that in 2012?
Your answer should be compact. 0.45. What is the ratio of the BoP (in US$) of Cote d'Ivoire in 2010 to that in 2011?
Your answer should be very brief. 7.62. What is the ratio of the BoP (in US$) of Cyprus in 2010 to that in 2011?
Make the answer very short. 0.87. What is the ratio of the BoP (in US$) of Namibia in 2010 to that in 2011?
Offer a very short reply. 0.6. What is the ratio of the BoP (in US$) of Cote d'Ivoire in 2010 to that in 2012?
Make the answer very short. 0.15. What is the ratio of the BoP (in US$) of Cyprus in 2010 to that in 2012?
Make the answer very short. 1.71. What is the ratio of the BoP (in US$) in Namibia in 2010 to that in 2012?
Your response must be concise. 0.76. What is the ratio of the BoP (in US$) in Cote d'Ivoire in 2011 to that in 2012?
Give a very brief answer. 0.02. What is the ratio of the BoP (in US$) of Cyprus in 2011 to that in 2012?
Provide a succinct answer. 1.97. What is the ratio of the BoP (in US$) of Namibia in 2011 to that in 2012?
Offer a very short reply. 1.25. What is the difference between the highest and the second highest BoP (in US$) of Cote d'Ivoire?
Offer a terse response. 6.93e+09. What is the difference between the highest and the second highest BoP (in US$) in Cyprus?
Give a very brief answer. 1.64e+07. What is the difference between the highest and the second highest BoP (in US$) of Namibia?
Give a very brief answer. 3.79e+07. What is the difference between the highest and the lowest BoP (in US$) of Austria?
Offer a very short reply. 1.54e+08. What is the difference between the highest and the lowest BoP (in US$) in Cote d'Ivoire?
Keep it short and to the point. 8.08e+09. What is the difference between the highest and the lowest BoP (in US$) in Cyprus?
Provide a short and direct response. 8.98e+07. What is the difference between the highest and the lowest BoP (in US$) of Namibia?
Offer a very short reply. 1.20e+08. 